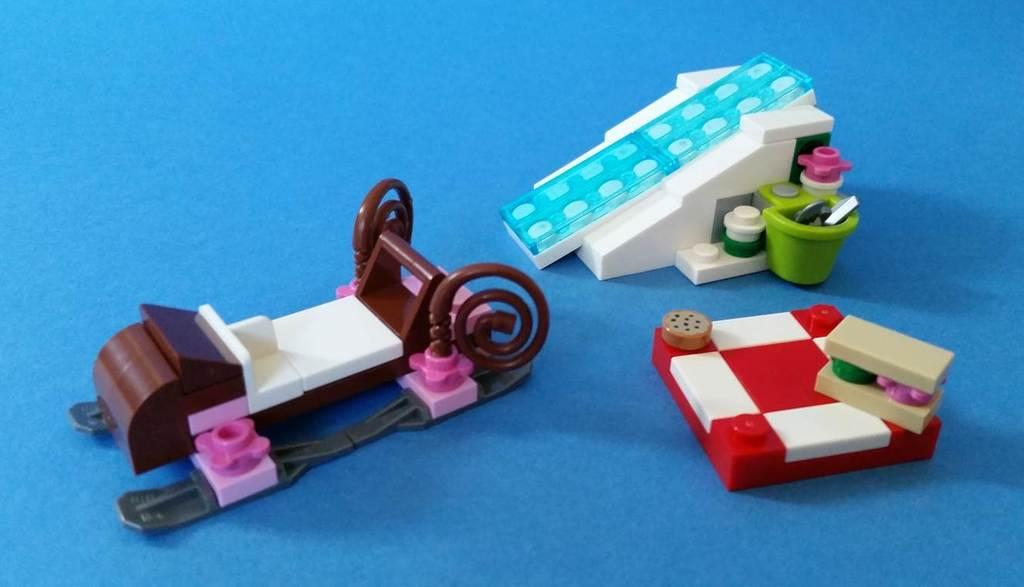How many toys are visible in the image? There are three toys in the image. What is the toys resting on or attached to? The toys are on an object. What type of holiday songs can be heard in the background of the image? There is no audio or reference to songs in the image, so it cannot be determined if any holiday songs are present. 